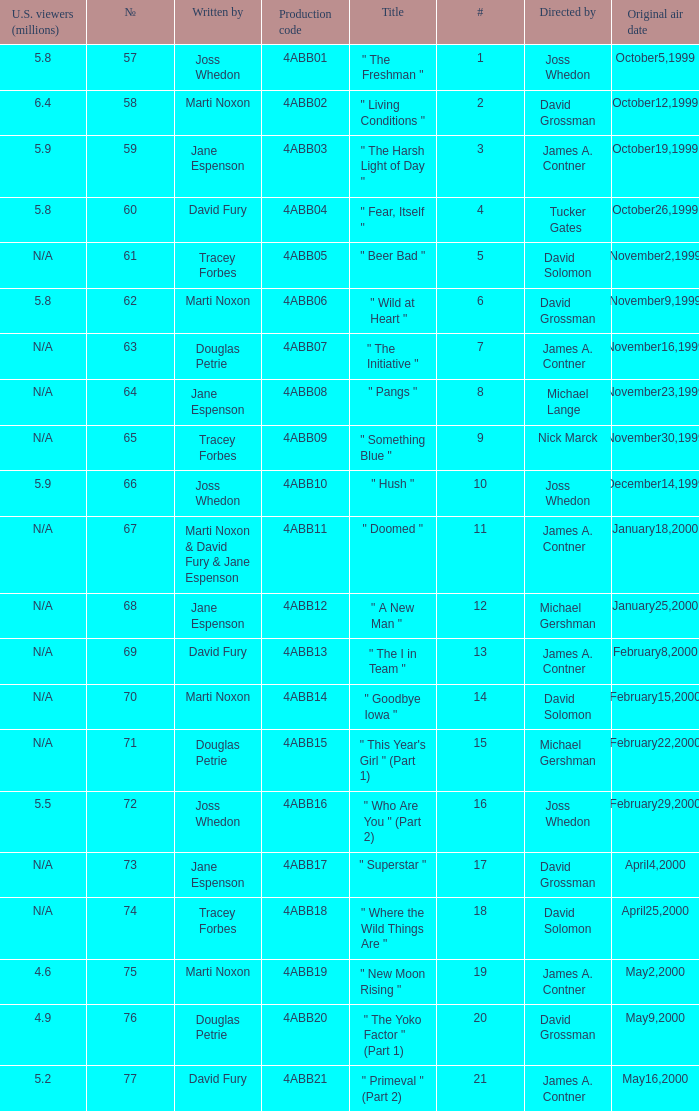What is the series No when the season 4 # is 18? 74.0. 